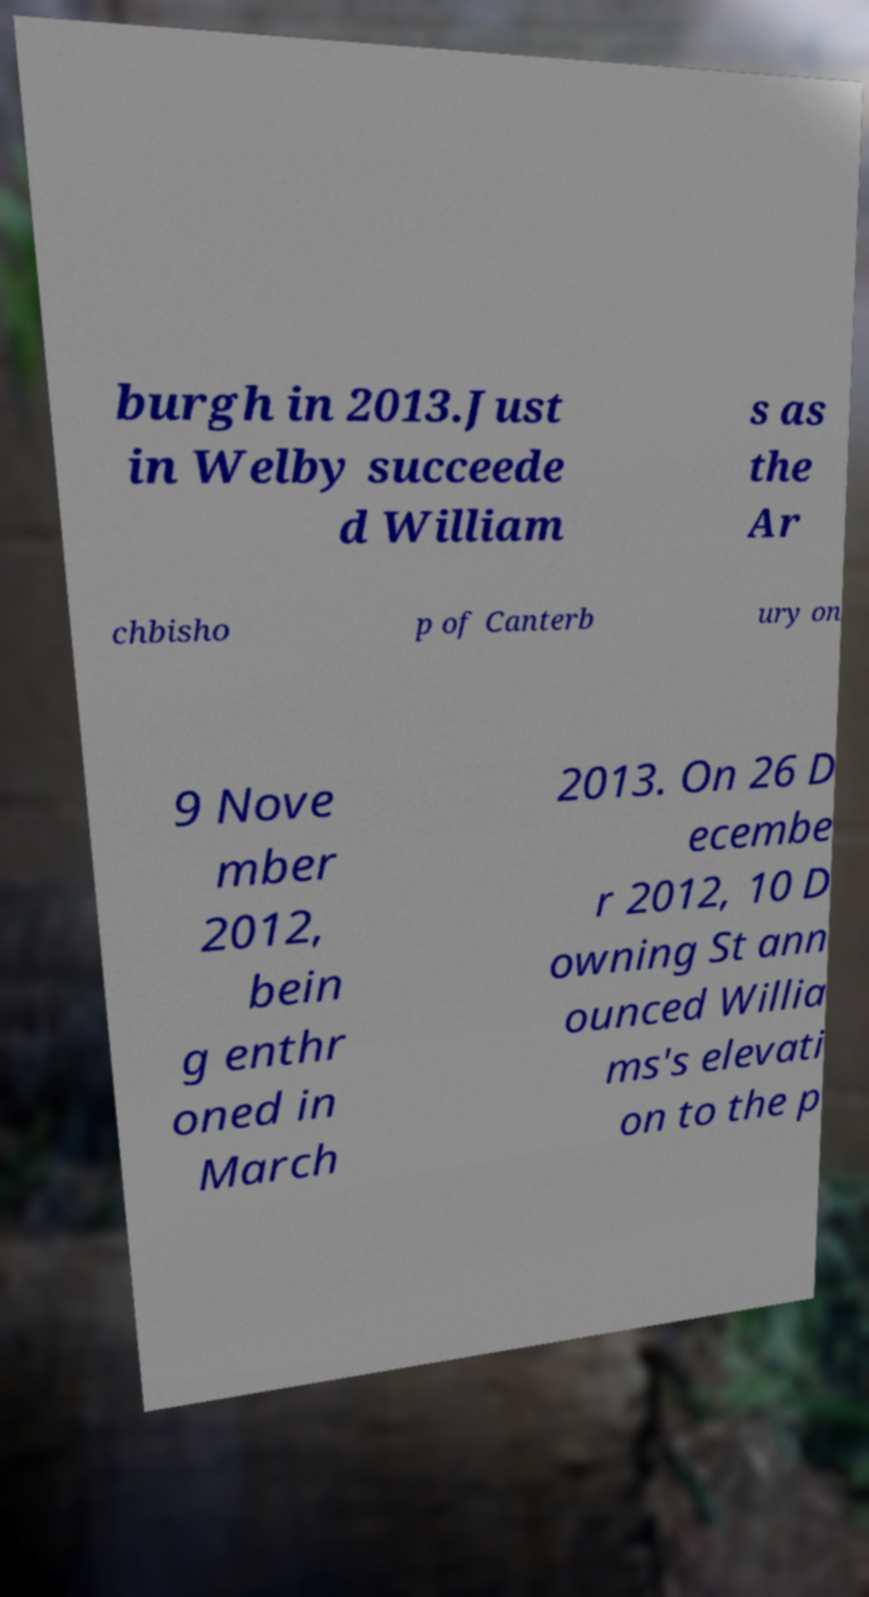Please read and relay the text visible in this image. What does it say? burgh in 2013.Just in Welby succeede d William s as the Ar chbisho p of Canterb ury on 9 Nove mber 2012, bein g enthr oned in March 2013. On 26 D ecembe r 2012, 10 D owning St ann ounced Willia ms's elevati on to the p 